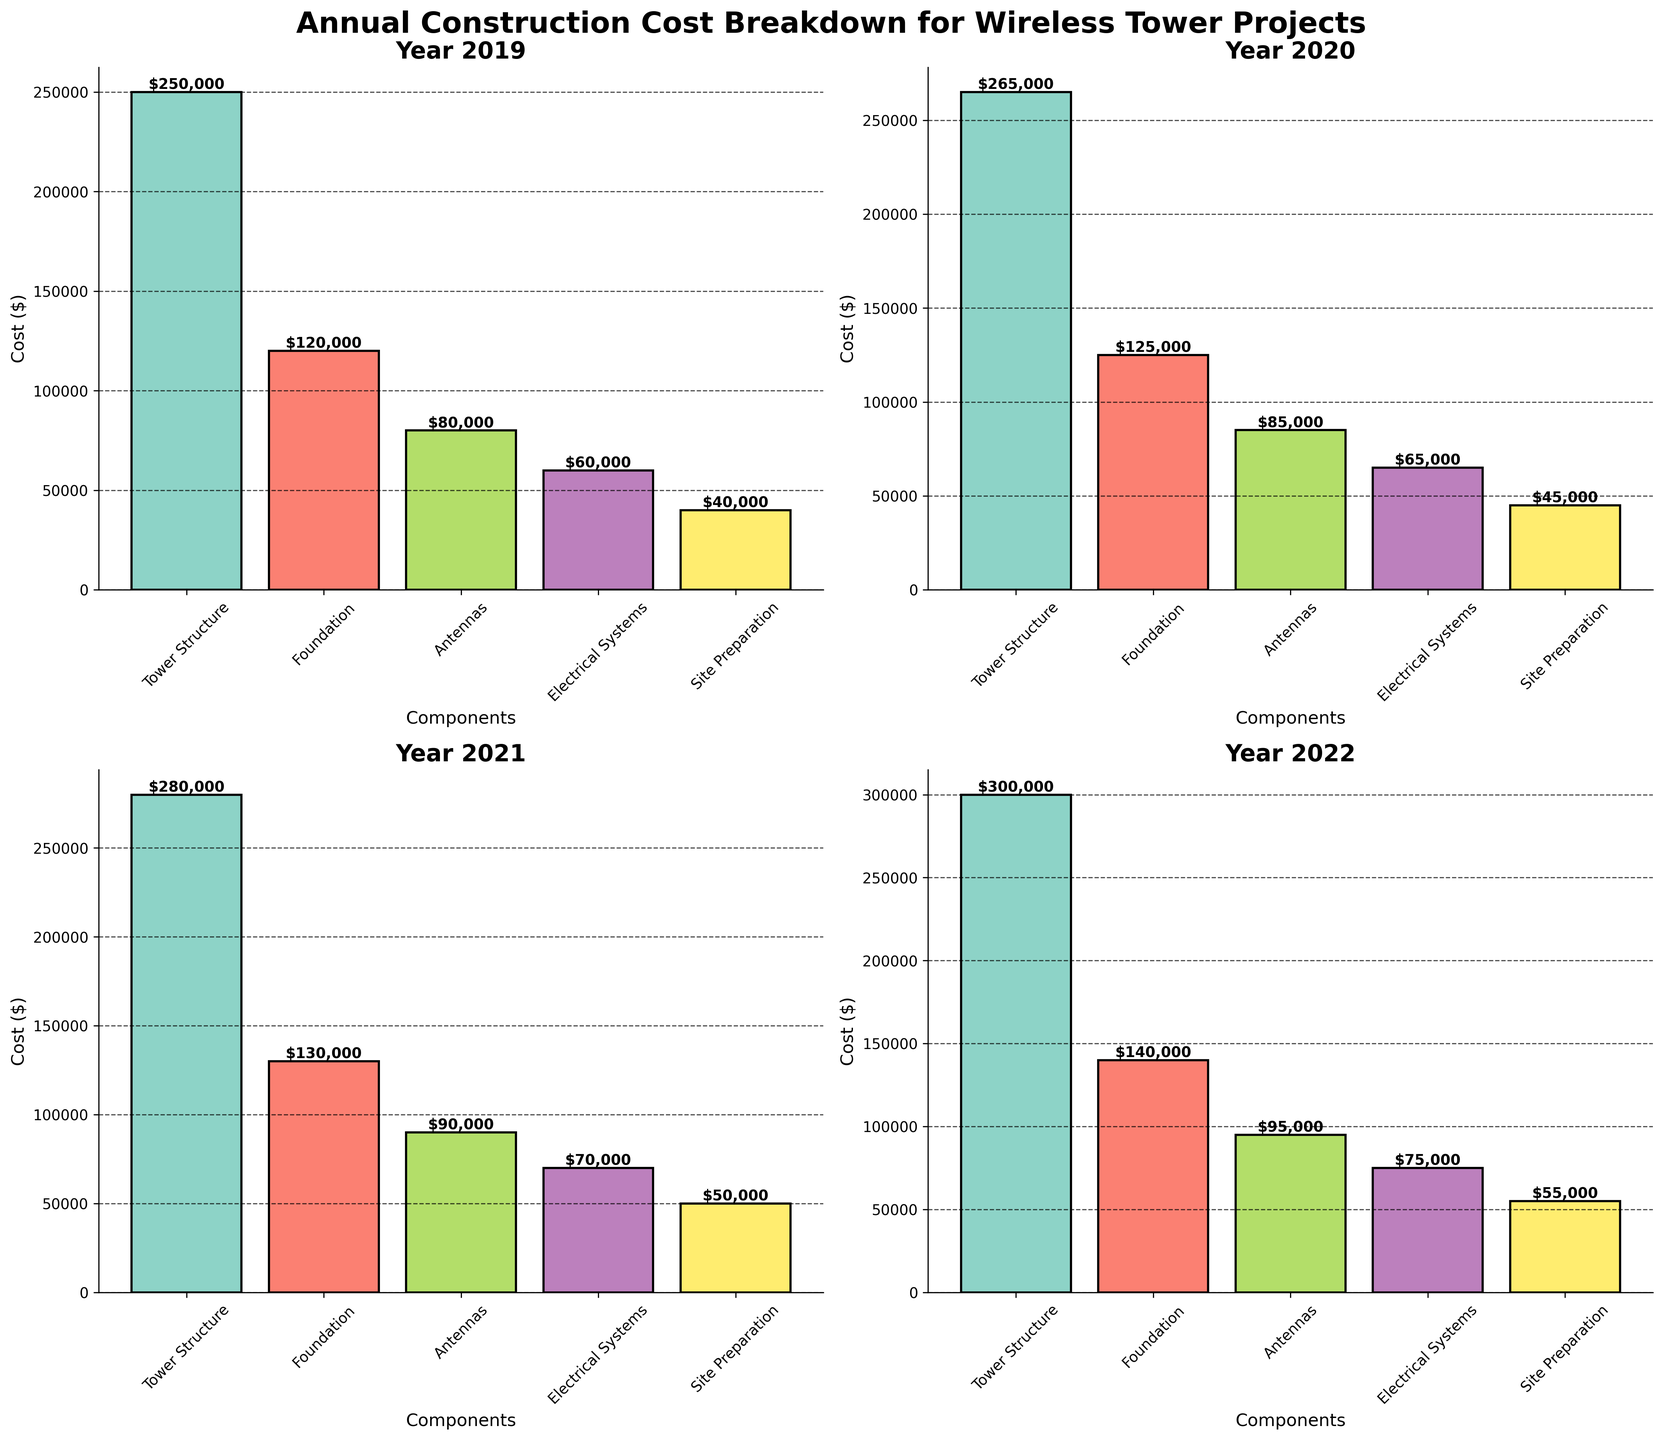How much did the cost of the Tower Structure component increase from 2019 to 2020? The cost of the Tower Structure in 2019 was $250,000, and in 2020 it was $265,000. The increase is $265,000 - $250,000 = $15,000.
Answer: $15,000 What is the total construction cost for all components in the year 2021? To find the total, sum the costs of all components in 2021: $280,000 + $130,000 + $90,000 + $70,000 + $50,000 = $620,000.
Answer: $620,000 Which component had the highest cost in 2022? By examining the bar heights for 2022, the Tower Structure has the highest cost at $300,000.
Answer: Tower Structure By how much did the cost of Site Preparation increase from 2019 to 2022? The cost of Site Preparation in 2019 was $40,000, and in 2022 it was $55,000. The increase is $55,000 - $40,000 = $15,000.
Answer: $15,000 Compare the total costs of all components between 2020 and 2022. Which year had the higher total cost and by how much? Sum the costs for 2020: $265,000 + $125,000 + $85,000 + $65,000 + $45,000 = $585,000. Sum the costs for 2022: $300,000 + $140,000 + $95,000 + $75,000 + $55,000 = $665,000. 2022 has the higher total cost by $665,000 - $585,000 = $80,000.
Answer: 2022 by $80,000 What is the average cost of the Foundation component from 2019 to 2022? To find the average, sum the costs for Foundation from 2019 to 2022: $120,000 + $125,000 + $130,000 + $140,000 = $515,000. Then divide by 4 years: $515,000 / 4 = $128,750.
Answer: $128,750 Which component showed the smallest increase in cost from 2019 to 2022? By examining the increase in costs: Tower Structure ($50,000), Foundation ($20,000), Antennas ($15,000), Electrical Systems ($15,000), and Site Preparation ($15,000). The Antennas, Electrical Systems, and Site Preparation each had the smallest increase of $15,000.
Answer: Antennas, Electrical Systems, Site Preparation What was the cost of Electrical Systems in 2020 and how does it compare to the cost in 2021? The cost of Electrical Systems in 2020 was $65,000, and in 2021 it was $70,000. Therefore, the cost increased by $70,000 - $65,000 = $5,000 from 2020 to 2021.
Answer: $5,000 increase 